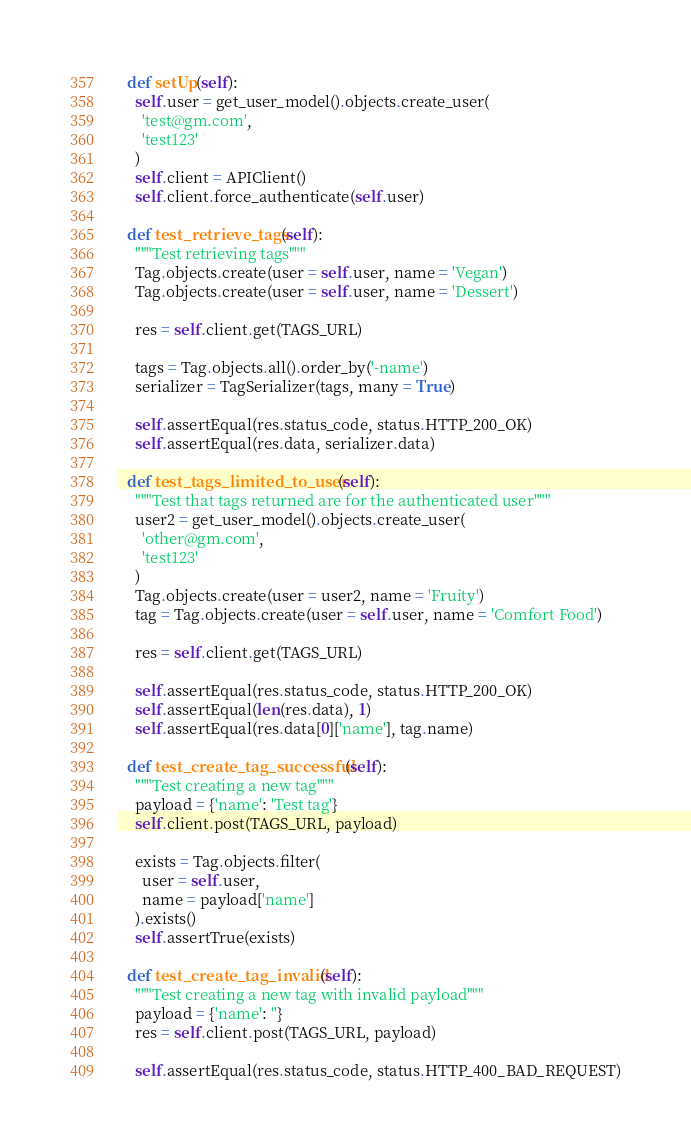Convert code to text. <code><loc_0><loc_0><loc_500><loc_500><_Python_>  def setUp(self):
    self.user = get_user_model().objects.create_user(
      'test@gm.com',
      'test123'
    )
    self.client = APIClient()
    self.client.force_authenticate(self.user)

  def test_retrieve_tags(self):
    """Test retrieving tags"""
    Tag.objects.create(user = self.user, name = 'Vegan')
    Tag.objects.create(user = self.user, name = 'Dessert')

    res = self.client.get(TAGS_URL)

    tags = Tag.objects.all().order_by('-name')
    serializer = TagSerializer(tags, many = True)

    self.assertEqual(res.status_code, status.HTTP_200_OK)
    self.assertEqual(res.data, serializer.data)

  def test_tags_limited_to_user(self):
    """Test that tags returned are for the authenticated user"""
    user2 = get_user_model().objects.create_user(
      'other@gm.com',
      'test123'
    )
    Tag.objects.create(user = user2, name = 'Fruity')
    tag = Tag.objects.create(user = self.user, name = 'Comfort Food')

    res = self.client.get(TAGS_URL)

    self.assertEqual(res.status_code, status.HTTP_200_OK)
    self.assertEqual(len(res.data), 1)
    self.assertEqual(res.data[0]['name'], tag.name)

  def test_create_tag_successful(self):
    """Test creating a new tag"""
    payload = {'name': 'Test tag'}
    self.client.post(TAGS_URL, payload)

    exists = Tag.objects.filter(
      user = self.user,
      name = payload['name']
    ).exists()
    self.assertTrue(exists)

  def test_create_tag_invalid(self):
    """Test creating a new tag with invalid payload"""
    payload = {'name': ''}
    res = self.client.post(TAGS_URL, payload)

    self.assertEqual(res.status_code, status.HTTP_400_BAD_REQUEST)
</code> 